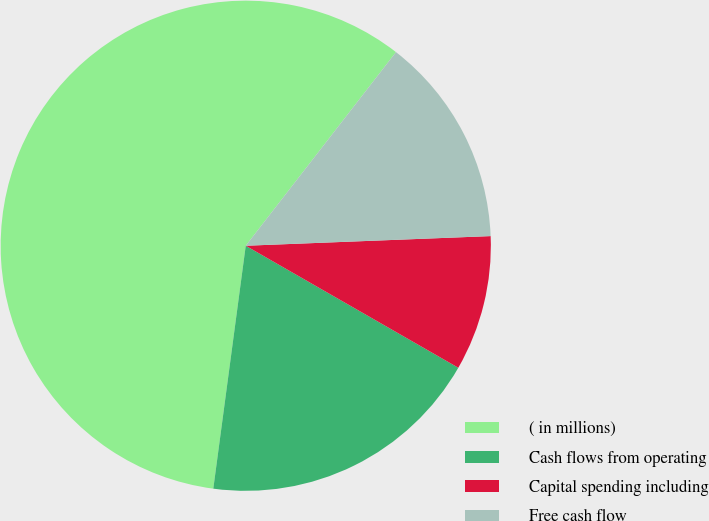<chart> <loc_0><loc_0><loc_500><loc_500><pie_chart><fcel>( in millions)<fcel>Cash flows from operating<fcel>Capital spending including<fcel>Free cash flow<nl><fcel>58.39%<fcel>18.82%<fcel>8.92%<fcel>13.87%<nl></chart> 